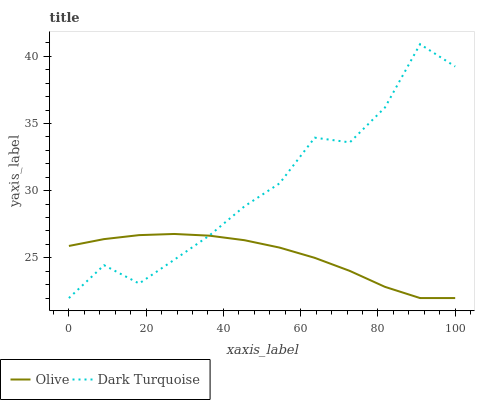Does Olive have the minimum area under the curve?
Answer yes or no. Yes. Does Dark Turquoise have the maximum area under the curve?
Answer yes or no. Yes. Does Dark Turquoise have the minimum area under the curve?
Answer yes or no. No. Is Olive the smoothest?
Answer yes or no. Yes. Is Dark Turquoise the roughest?
Answer yes or no. Yes. Is Dark Turquoise the smoothest?
Answer yes or no. No. Does Olive have the lowest value?
Answer yes or no. Yes. Does Dark Turquoise have the highest value?
Answer yes or no. Yes. Does Dark Turquoise intersect Olive?
Answer yes or no. Yes. Is Dark Turquoise less than Olive?
Answer yes or no. No. Is Dark Turquoise greater than Olive?
Answer yes or no. No. 